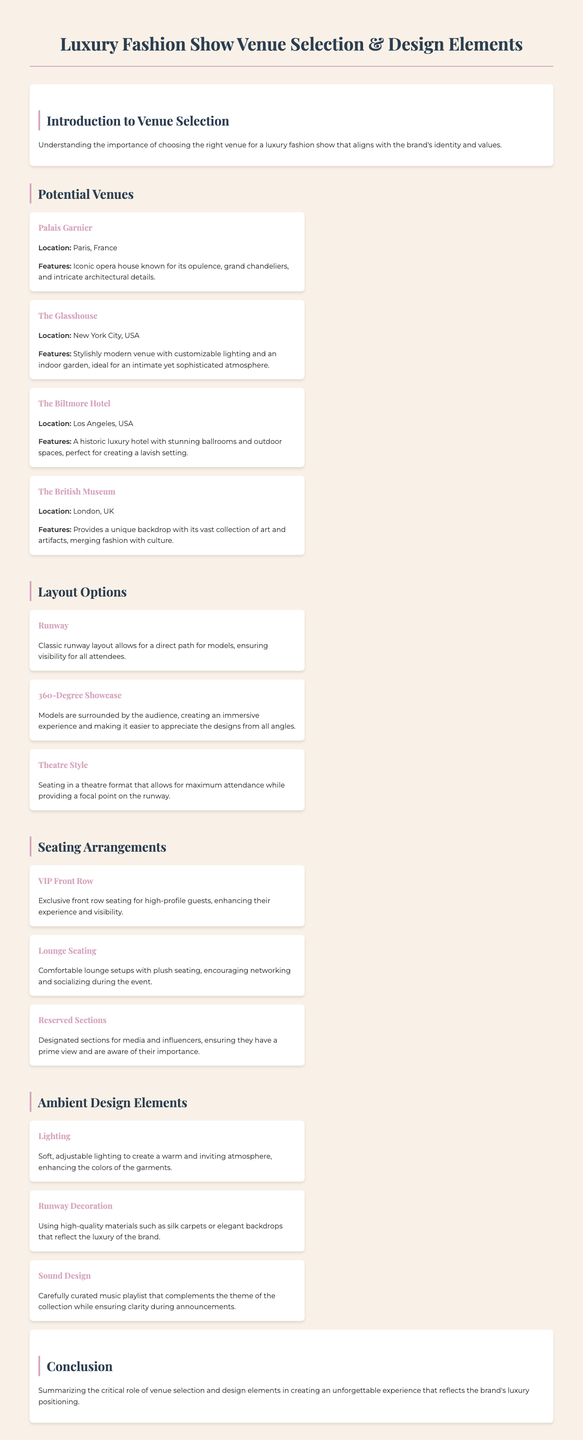what is the location of Palais Garnier? Palais Garnier is located in Paris, France as mentioned in the document.
Answer: Paris, France what are the features of The Glasshouse? The features include a stylishly modern venue with customizable lighting and an indoor garden, ideal for an intimate yet sophisticated atmosphere.
Answer: Customizable lighting and indoor garden how many layout options are mentioned? The document lists three layout options in the layout section.
Answer: Three what is the seating arrangement for VIP guests? The VIP Front Row seating is exclusive for high-profile guests to enhance their experience and visibility.
Answer: VIP Front Row what is the focus of the ambient design element section? The focus is on elements like lighting, runway decoration, and sound design to create a luxurious atmosphere.
Answer: Lighting, runway decoration, and sound design which venue provides a unique cultural backdrop? The British Museum is noted for providing a unique backdrop with its vast collection of art and artifacts.
Answer: The British Museum how many seating arrangements are discussed in the document? There are three seating arrangements highlighted in the seating section of the document.
Answer: Three what type of lighting is suggested for the show? Soft, adjustable lighting is recommended to create a warm and inviting atmosphere.
Answer: Soft, adjustable lighting what does the conclusion summarize? The conclusion summarizes the critical role of venue selection and design elements in creating an unforgettable experience.
Answer: Venue selection and design elements 